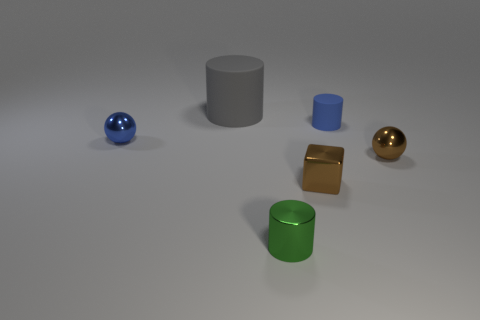Subtract all yellow cubes. Subtract all brown cylinders. How many cubes are left? 1 Subtract all cyan cylinders. How many green cubes are left? 0 Add 1 tiny objects. How many grays exist? 0 Subtract all small gray balls. Subtract all tiny things. How many objects are left? 1 Add 3 cylinders. How many cylinders are left? 6 Add 2 tiny blue objects. How many tiny blue objects exist? 4 Add 3 small brown spheres. How many objects exist? 9 Subtract all gray cylinders. How many cylinders are left? 2 Subtract all tiny matte cylinders. How many cylinders are left? 2 Subtract 1 green cylinders. How many objects are left? 5 